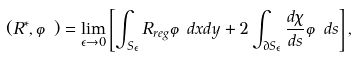<formula> <loc_0><loc_0><loc_500><loc_500>( R ^ { * } , \varphi ) = \lim _ { \epsilon \rightarrow 0 } \left [ \int _ { S _ { \epsilon } } R _ { r e g } \varphi d x d y + 2 \int _ { \partial S _ { \epsilon } } \frac { d \chi } { d s } \varphi d s \right ] ,</formula> 